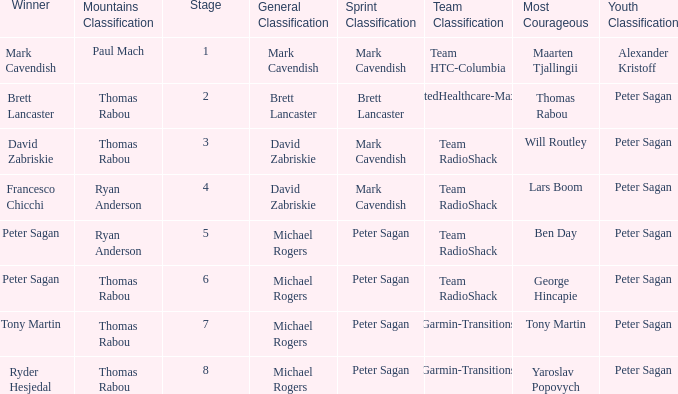When Ryan Anderson won the mountains classification, and Michael Rogers won the general classification, who won the sprint classification? Peter Sagan. 